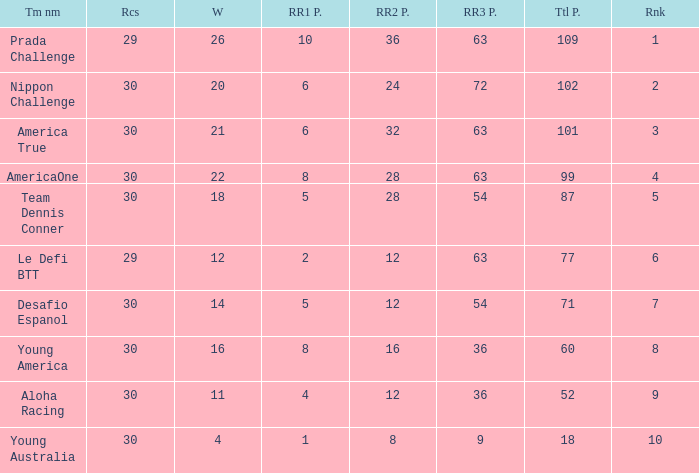Name the total number of rr2 pts for won being 11 1.0. 